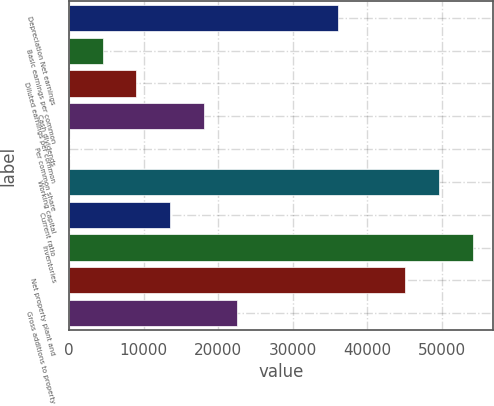Convert chart to OTSL. <chart><loc_0><loc_0><loc_500><loc_500><bar_chart><fcel>Depreciation Net earnings<fcel>Basic earnings per common<fcel>Diluted earnings per common<fcel>Cash dividends<fcel>Per common share<fcel>Working capital<fcel>Current ratio<fcel>Inventories<fcel>Net property plant and<fcel>Gross additions to property<nl><fcel>36108.9<fcel>4513.92<fcel>9027.49<fcel>18054.6<fcel>0.35<fcel>49649.6<fcel>13541.1<fcel>54163.2<fcel>45136<fcel>22568.2<nl></chart> 